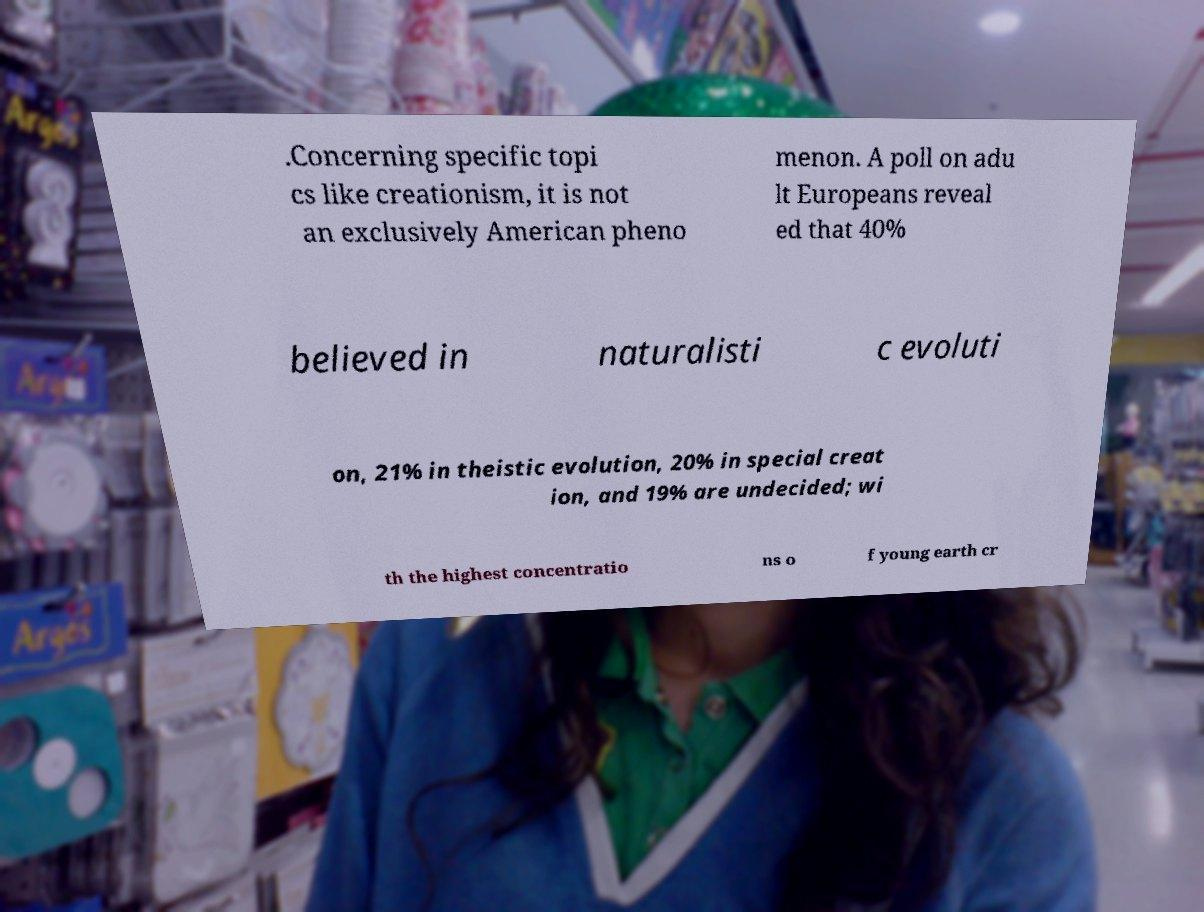Please read and relay the text visible in this image. What does it say? .Concerning specific topi cs like creationism, it is not an exclusively American pheno menon. A poll on adu lt Europeans reveal ed that 40% believed in naturalisti c evoluti on, 21% in theistic evolution, 20% in special creat ion, and 19% are undecided; wi th the highest concentratio ns o f young earth cr 